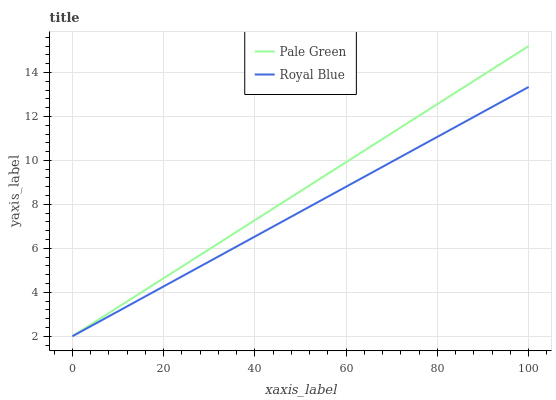Does Royal Blue have the minimum area under the curve?
Answer yes or no. Yes. Does Pale Green have the maximum area under the curve?
Answer yes or no. Yes. Does Pale Green have the minimum area under the curve?
Answer yes or no. No. Is Royal Blue the smoothest?
Answer yes or no. Yes. Is Pale Green the roughest?
Answer yes or no. Yes. Is Pale Green the smoothest?
Answer yes or no. No. Does Royal Blue have the lowest value?
Answer yes or no. Yes. Does Pale Green have the highest value?
Answer yes or no. Yes. Does Royal Blue intersect Pale Green?
Answer yes or no. Yes. Is Royal Blue less than Pale Green?
Answer yes or no. No. Is Royal Blue greater than Pale Green?
Answer yes or no. No. 